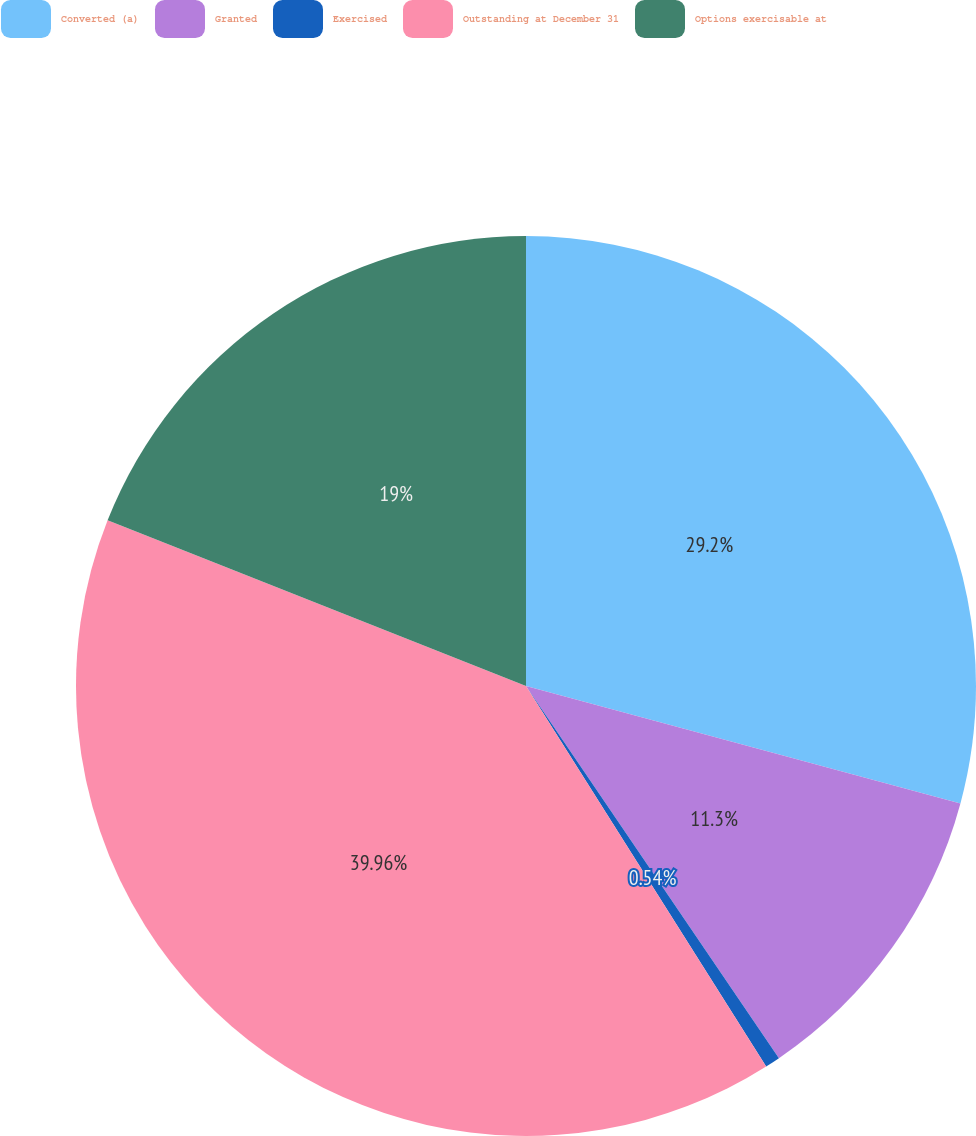Convert chart. <chart><loc_0><loc_0><loc_500><loc_500><pie_chart><fcel>Converted (a)<fcel>Granted<fcel>Exercised<fcel>Outstanding at December 31<fcel>Options exercisable at<nl><fcel>29.2%<fcel>11.3%<fcel>0.54%<fcel>39.96%<fcel>19.0%<nl></chart> 